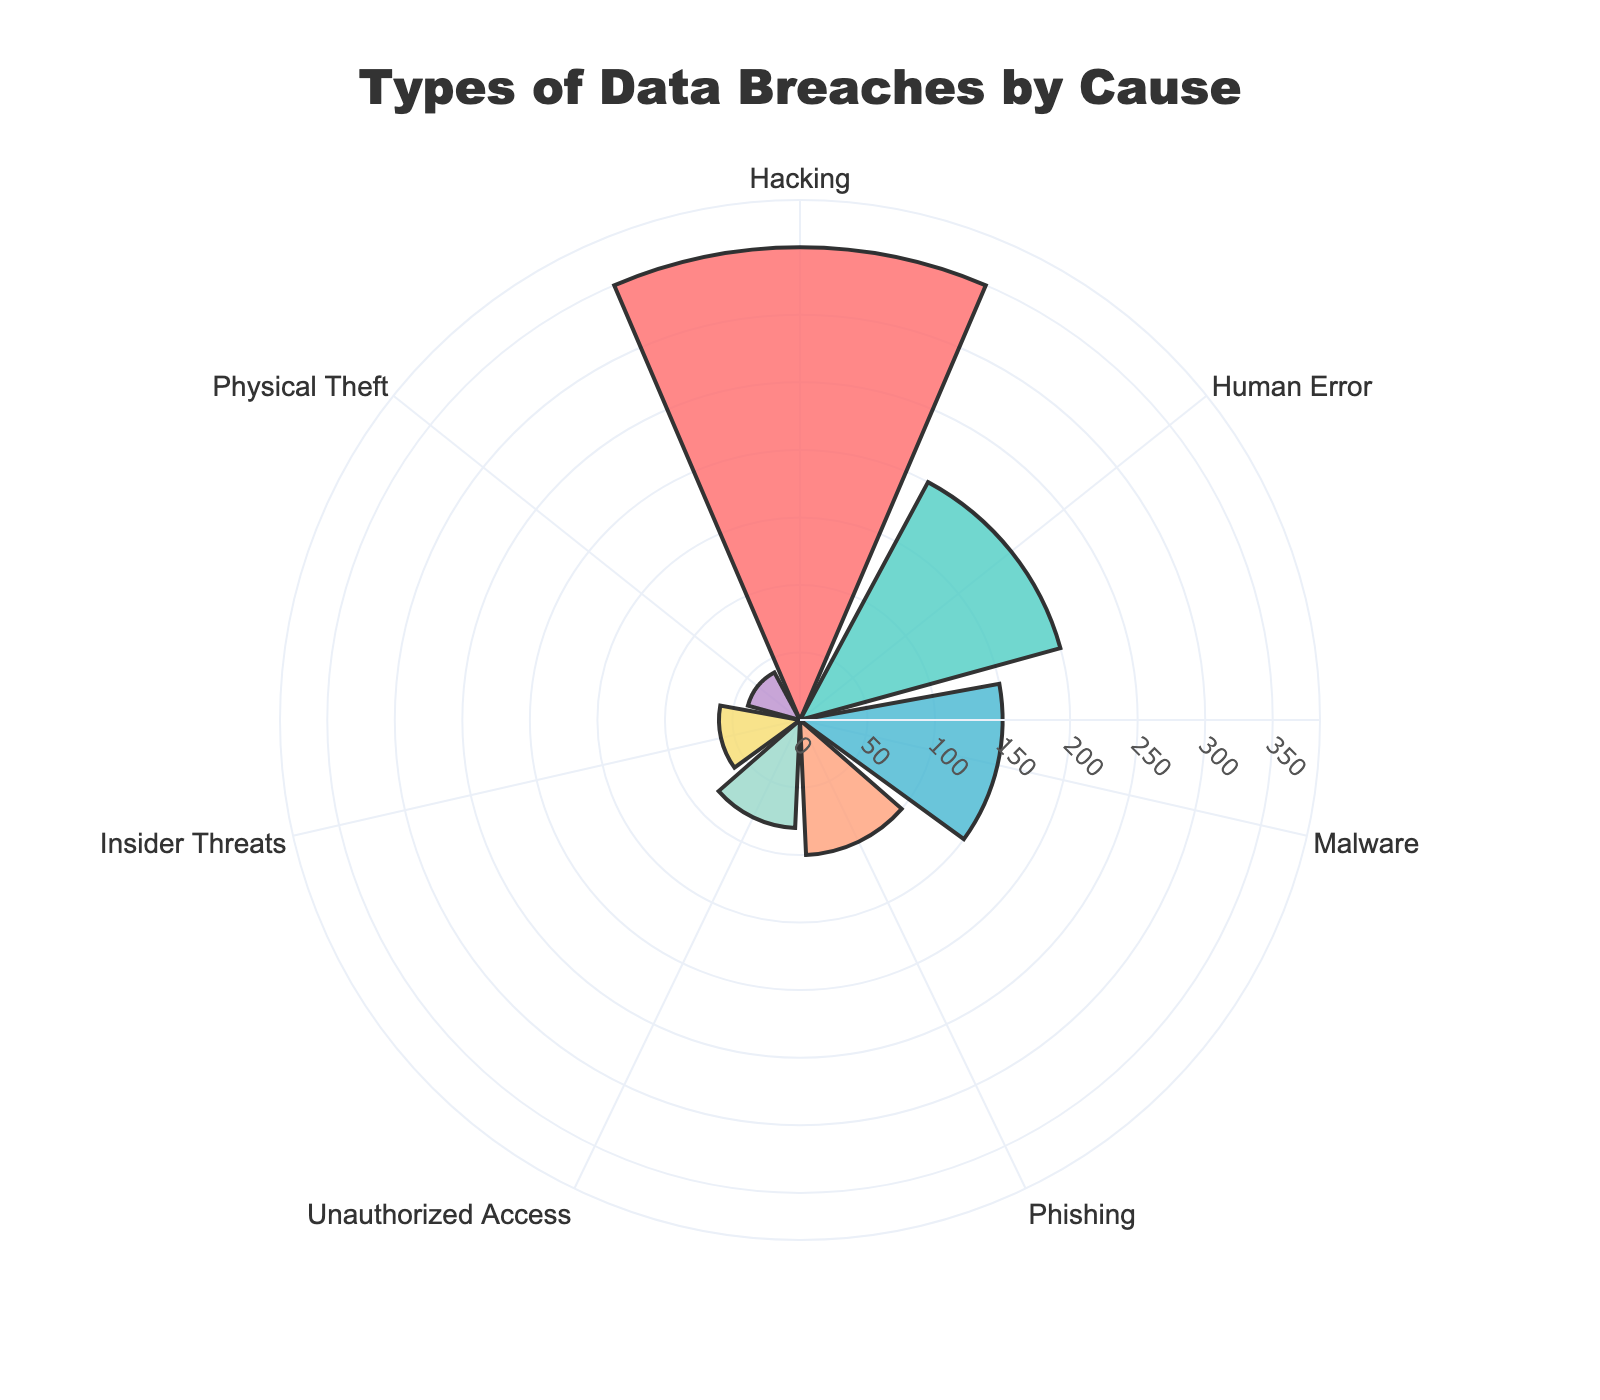what is the title of the chart? The title is usually at the top of the figure, serving to summarize what the chart is about. In this case, the title displayed prominently at the top.
Answer: Types of Data Breaches by Cause Which cause has the highest number of occurrences? To find the cause with the highest number, look for the largest radius in the polar area chart.
Answer: Hacking Which cause has the second-highest number of occurrences? Look for the second-largest radius in the chart, following the largest one.
Answer: Human Error How many more occurrences does hacking have compared to physical theft? Find the difference between the occurrence value of hacking and physical theft by subtracting the smaller number from the larger one.
Answer: 310 What is the combined total number of occurrences for human error, phishing, and physical theft? Sum the occurrences of these three causes: Human Error (200) + Phishing (100) + Physical Theft (40).
Answer: 340 Which causes have fewer than 100 occurrences? Identify the segments with radii less than the value representing 100 occurrences.
Answer: Unauthorized Access, Insider Threats, Physical Theft How does the number of occurrences of malware compare to phishing? Compare the radii: Malware has 150 occurrences, Phishing has 100 occurrences.
Answer: Malware has more occurrences than Phishing What percentage of total occurrences does human error represent? Calculate the percentage: (Occurrences of human error / Total occurrences) * 100. First, sum all occurrences, which equals 980. Then, (200/980) * 100 = 20.41%.
Answer: Approximately 20.41% Which cause has the smallest number of occurrences, and what is that value? Identify the segment with the smallest radius and note its corresponding value.
Answer: Physical Theft, 40 Arrange the causes in ascending order based on the number of occurrences. Order the segments from the smallest to the largest radius.
Answer: Physical Theft, Insider Threats, Unauthorized Access, Phishing, Malware, Human Error, Hacking 